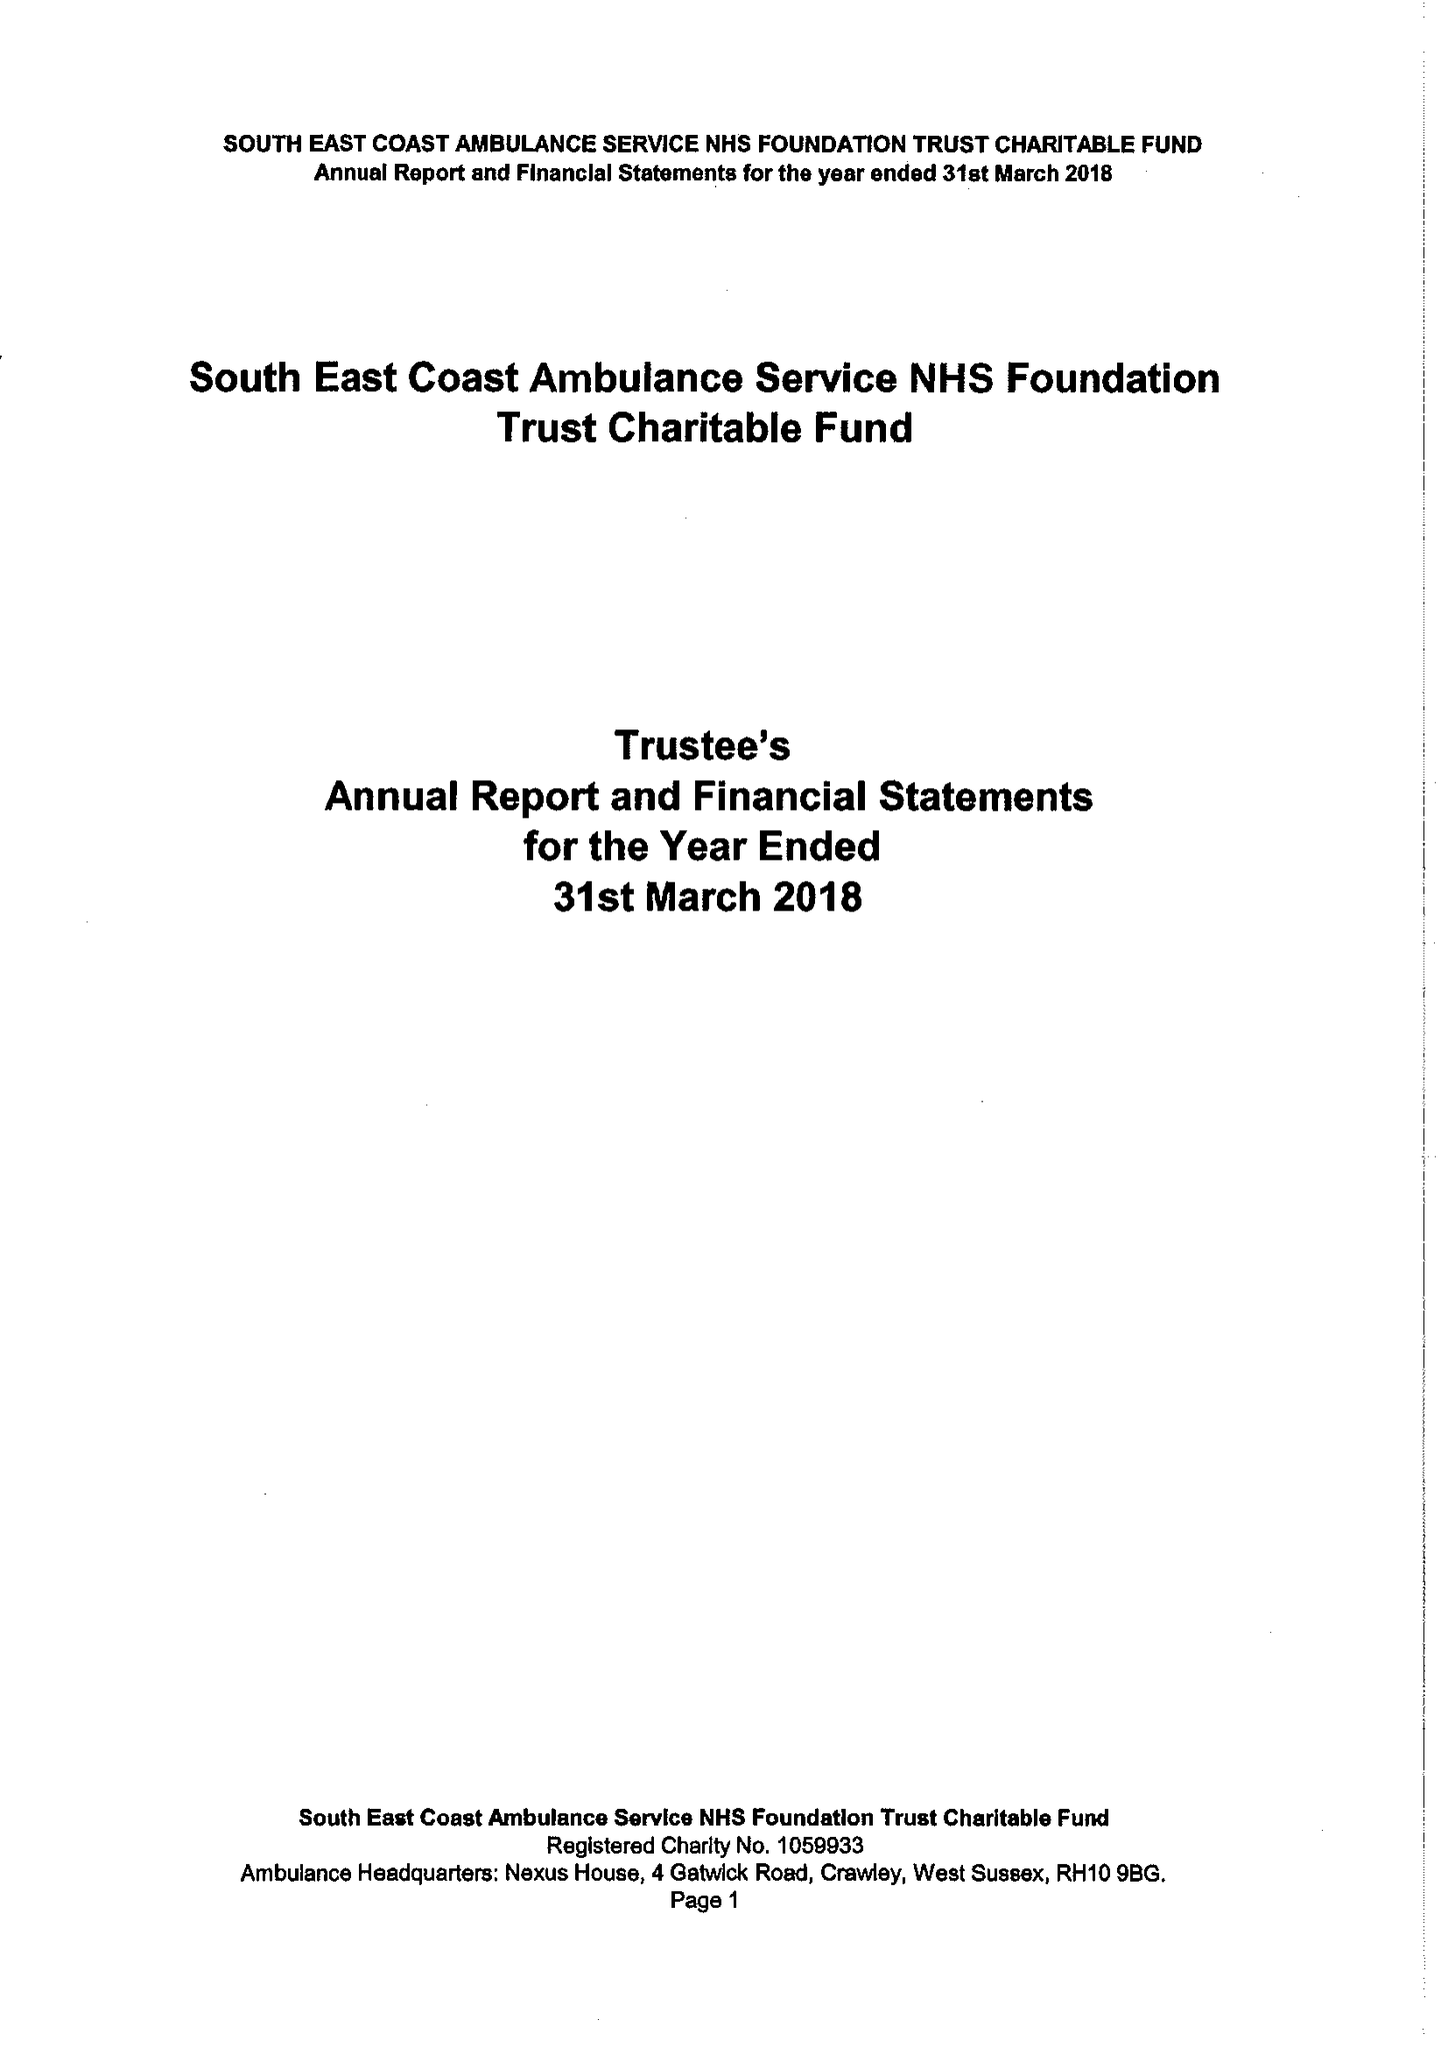What is the value for the spending_annually_in_british_pounds?
Answer the question using a single word or phrase. 44000.00 